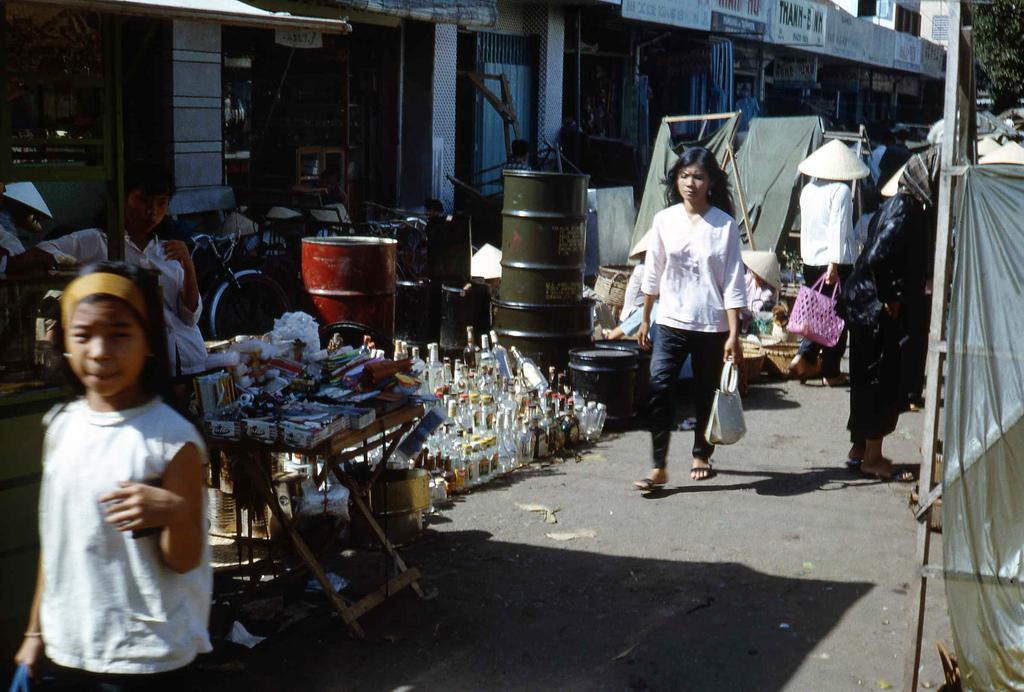Can you describe this image briefly? At the bottom, we see the road. On the right side, we see a sheet in white color. Beside that, we see a woman is standing. In the middle, we see a woman is holding a handbag. Behind her, we see a woman is holding a pink basket. At the bottom, we see a girl is standing. Beside her, we see a table on which the objects are placed. Beside that, we see a man is standing. Behind him, we see the bicycles and a red color drum. Beside that, we see the glass bottles are placed on the road. Beside that, we see the drums in green color. Behind that, we see a grey color sheet. There are trees and buildings in the background. In the background, we see the people are standing. 